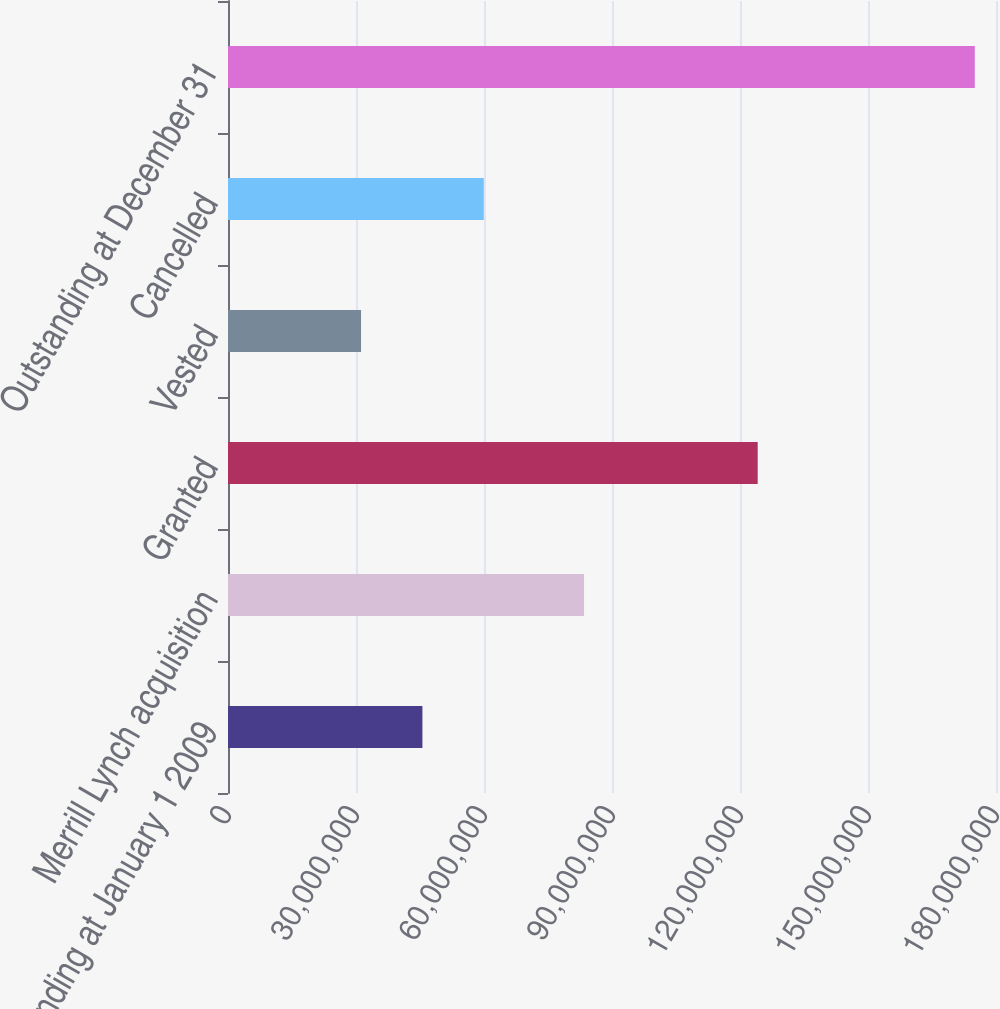<chart> <loc_0><loc_0><loc_500><loc_500><bar_chart><fcel>Outstanding at January 1 2009<fcel>Merrill Lynch acquisition<fcel>Granted<fcel>Vested<fcel>Cancelled<fcel>Outstanding at December 31<nl><fcel>4.5566e+07<fcel>8.34461e+07<fcel>1.24147e+08<fcel>3.11814e+07<fcel>5.99507e+07<fcel>1.75028e+08<nl></chart> 